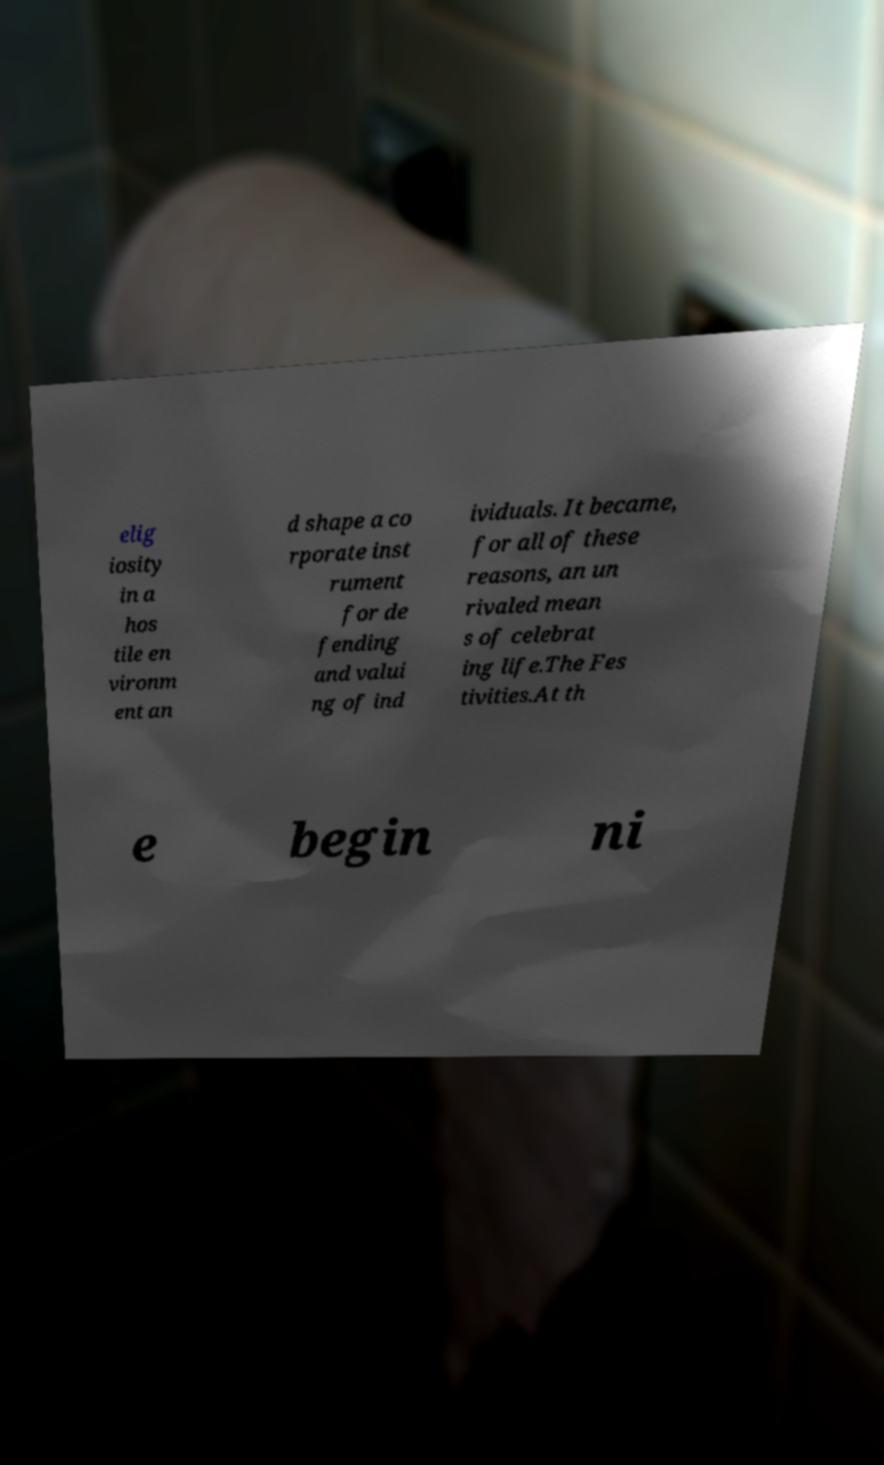There's text embedded in this image that I need extracted. Can you transcribe it verbatim? elig iosity in a hos tile en vironm ent an d shape a co rporate inst rument for de fending and valui ng of ind ividuals. It became, for all of these reasons, an un rivaled mean s of celebrat ing life.The Fes tivities.At th e begin ni 